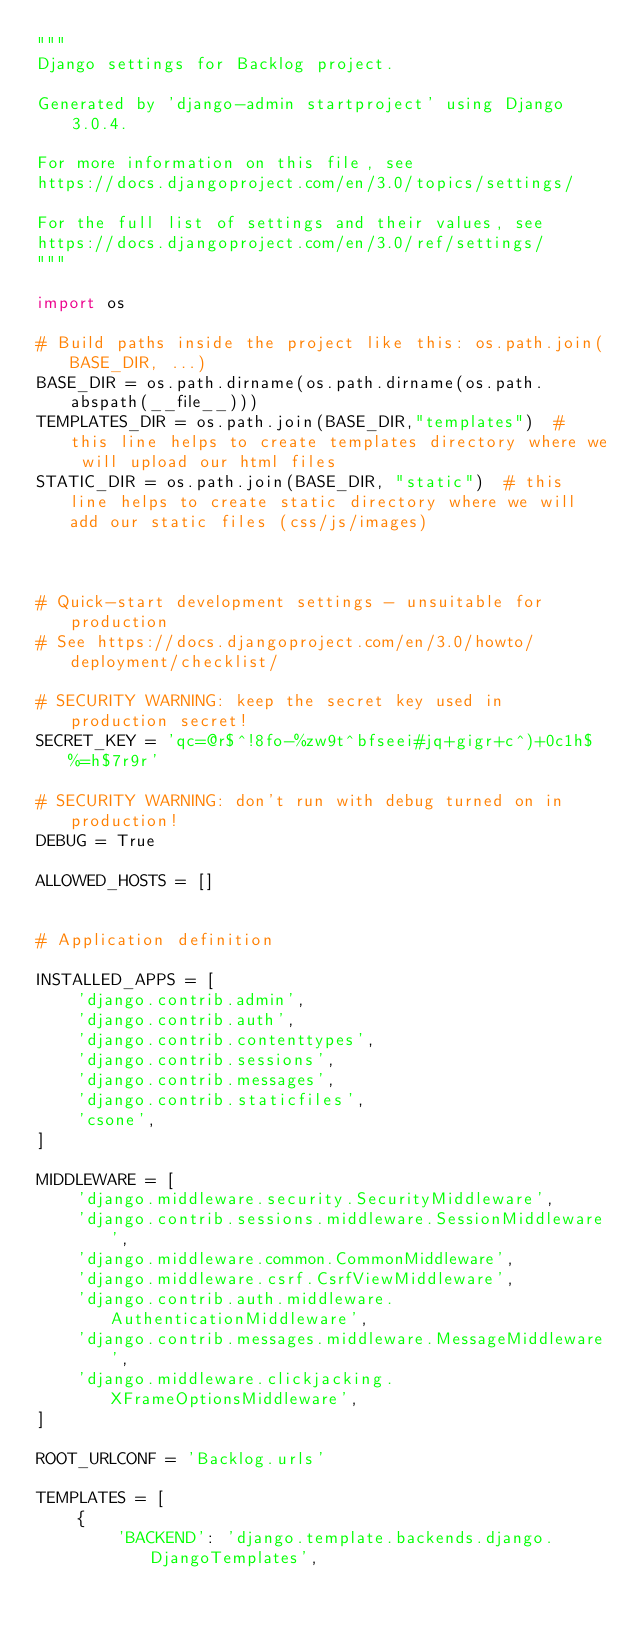<code> <loc_0><loc_0><loc_500><loc_500><_Python_>"""
Django settings for Backlog project.

Generated by 'django-admin startproject' using Django 3.0.4.

For more information on this file, see
https://docs.djangoproject.com/en/3.0/topics/settings/

For the full list of settings and their values, see
https://docs.djangoproject.com/en/3.0/ref/settings/
"""

import os

# Build paths inside the project like this: os.path.join(BASE_DIR, ...)
BASE_DIR = os.path.dirname(os.path.dirname(os.path.abspath(__file__)))
TEMPLATES_DIR = os.path.join(BASE_DIR,"templates")  # this line helps to create templates directory where we will upload our html files
STATIC_DIR = os.path.join(BASE_DIR, "static")  # this line helps to create static directory where we will add our static files (css/js/images)



# Quick-start development settings - unsuitable for production
# See https://docs.djangoproject.com/en/3.0/howto/deployment/checklist/

# SECURITY WARNING: keep the secret key used in production secret!
SECRET_KEY = 'qc=@r$^!8fo-%zw9t^bfseei#jq+gigr+c^)+0c1h$%=h$7r9r'

# SECURITY WARNING: don't run with debug turned on in production!
DEBUG = True

ALLOWED_HOSTS = []


# Application definition

INSTALLED_APPS = [
    'django.contrib.admin',
    'django.contrib.auth',
    'django.contrib.contenttypes',
    'django.contrib.sessions',
    'django.contrib.messages',
    'django.contrib.staticfiles',
    'csone',
]

MIDDLEWARE = [
    'django.middleware.security.SecurityMiddleware',
    'django.contrib.sessions.middleware.SessionMiddleware',
    'django.middleware.common.CommonMiddleware',
    'django.middleware.csrf.CsrfViewMiddleware',
    'django.contrib.auth.middleware.AuthenticationMiddleware',
    'django.contrib.messages.middleware.MessageMiddleware',
    'django.middleware.clickjacking.XFrameOptionsMiddleware',
]

ROOT_URLCONF = 'Backlog.urls'

TEMPLATES = [
    {
        'BACKEND': 'django.template.backends.django.DjangoTemplates',</code> 